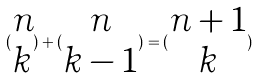<formula> <loc_0><loc_0><loc_500><loc_500>( \begin{matrix} n \\ k \end{matrix} ) + ( \begin{matrix} n \\ k - 1 \end{matrix} ) = ( \begin{matrix} n + 1 \\ k \end{matrix} )</formula> 